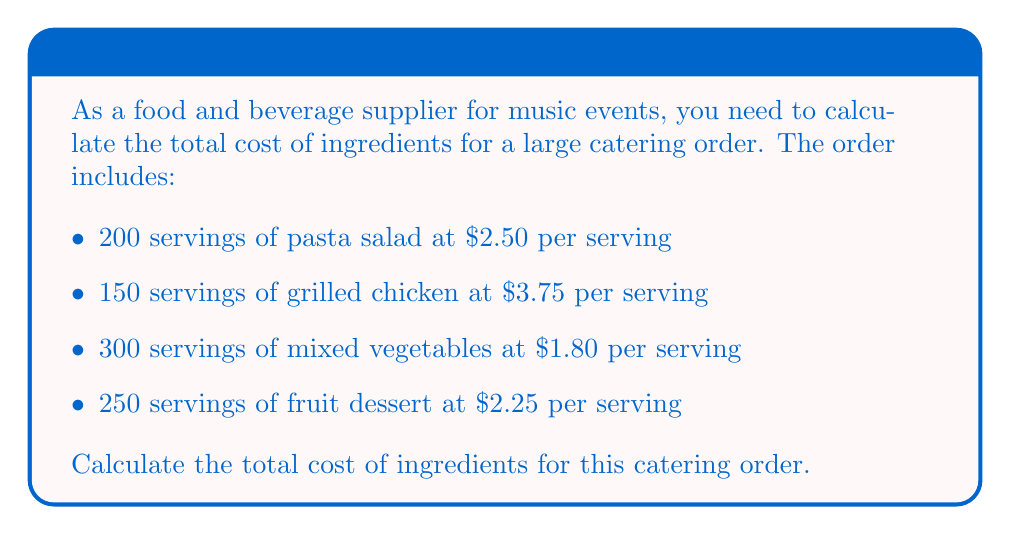Help me with this question. To calculate the total cost of ingredients, we need to multiply the number of servings for each item by its cost per serving and then sum up all the results. Let's break it down step by step:

1. Pasta salad:
   $200 \times \$2.50 = \$500$

2. Grilled chicken:
   $150 \times \$3.75 = \$562.50$

3. Mixed vegetables:
   $300 \times \$1.80 = \$540$

4. Fruit dessert:
   $250 \times \$2.25 = \$562.50$

Now, we sum up all these costs:

$$\text{Total cost} = \$500 + \$562.50 + \$540 + \$562.50$$

$$\text{Total cost} = \$2,165$$
Answer: $2,165 